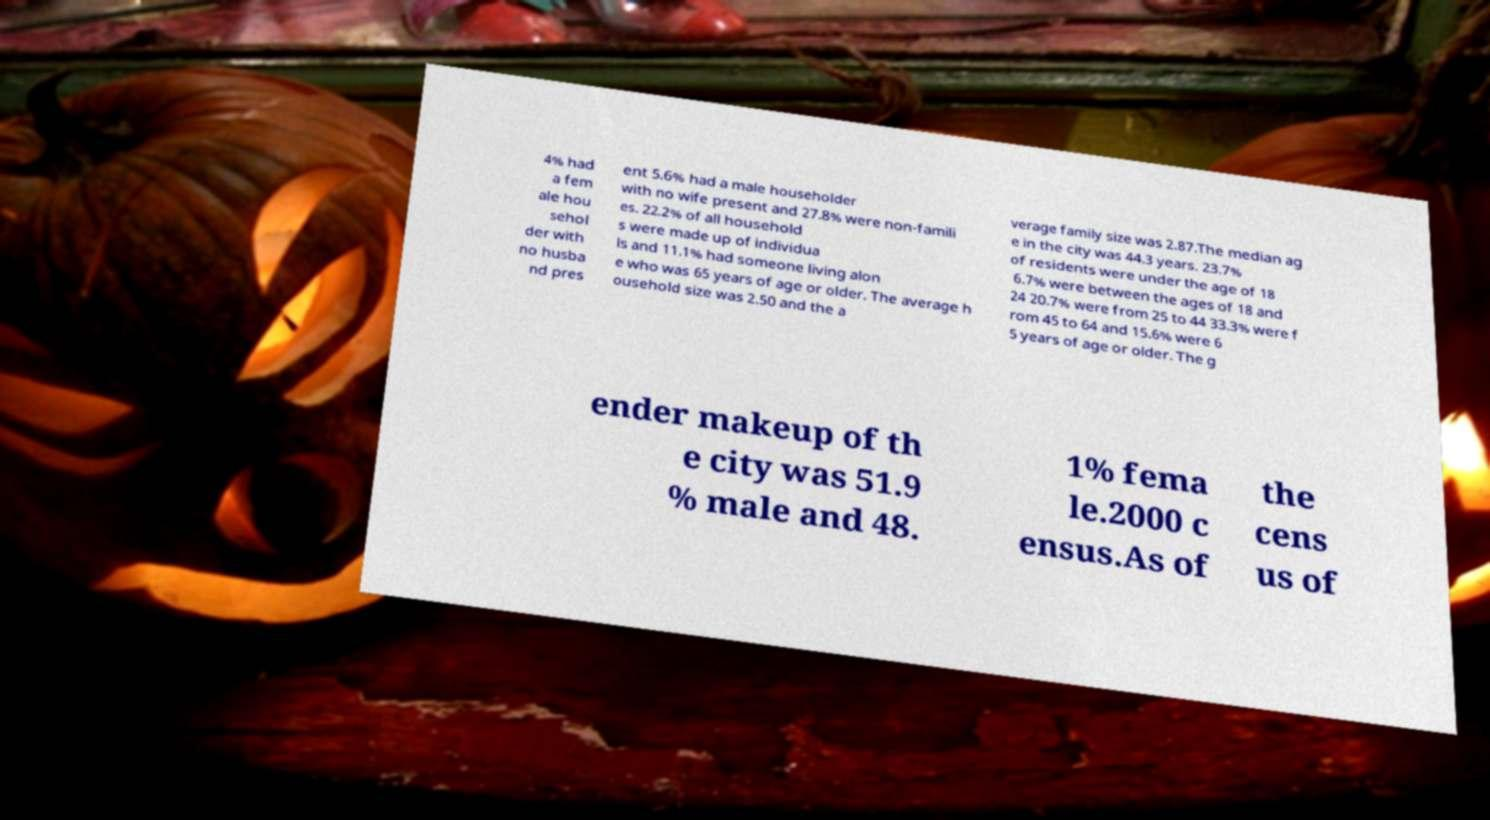For documentation purposes, I need the text within this image transcribed. Could you provide that? 4% had a fem ale hou sehol der with no husba nd pres ent 5.6% had a male householder with no wife present and 27.8% were non-famili es. 22.2% of all household s were made up of individua ls and 11.1% had someone living alon e who was 65 years of age or older. The average h ousehold size was 2.50 and the a verage family size was 2.87.The median ag e in the city was 44.3 years. 23.7% of residents were under the age of 18 6.7% were between the ages of 18 and 24 20.7% were from 25 to 44 33.3% were f rom 45 to 64 and 15.6% were 6 5 years of age or older. The g ender makeup of th e city was 51.9 % male and 48. 1% fema le.2000 c ensus.As of the cens us of 